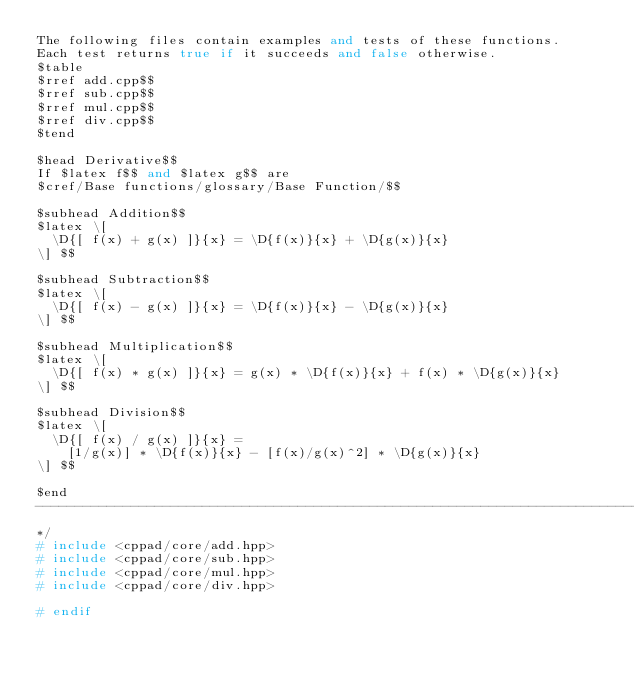<code> <loc_0><loc_0><loc_500><loc_500><_C++_>The following files contain examples and tests of these functions.
Each test returns true if it succeeds and false otherwise.
$table
$rref add.cpp$$
$rref sub.cpp$$
$rref mul.cpp$$
$rref div.cpp$$
$tend

$head Derivative$$
If $latex f$$ and $latex g$$ are
$cref/Base functions/glossary/Base Function/$$

$subhead Addition$$
$latex \[
	\D{[ f(x) + g(x) ]}{x} = \D{f(x)}{x} + \D{g(x)}{x}
\] $$

$subhead Subtraction$$
$latex \[
	\D{[ f(x) - g(x) ]}{x} = \D{f(x)}{x} - \D{g(x)}{x}
\] $$

$subhead Multiplication$$
$latex \[
	\D{[ f(x) * g(x) ]}{x} = g(x) * \D{f(x)}{x} + f(x) * \D{g(x)}{x}
\] $$

$subhead Division$$
$latex \[
	\D{[ f(x) / g(x) ]}{x} =
		[1/g(x)] * \D{f(x)}{x} - [f(x)/g(x)^2] * \D{g(x)}{x}
\] $$

$end
-----------------------------------------------------------------------------
*/
# include <cppad/core/add.hpp>
# include <cppad/core/sub.hpp>
# include <cppad/core/mul.hpp>
# include <cppad/core/div.hpp>

# endif
</code> 